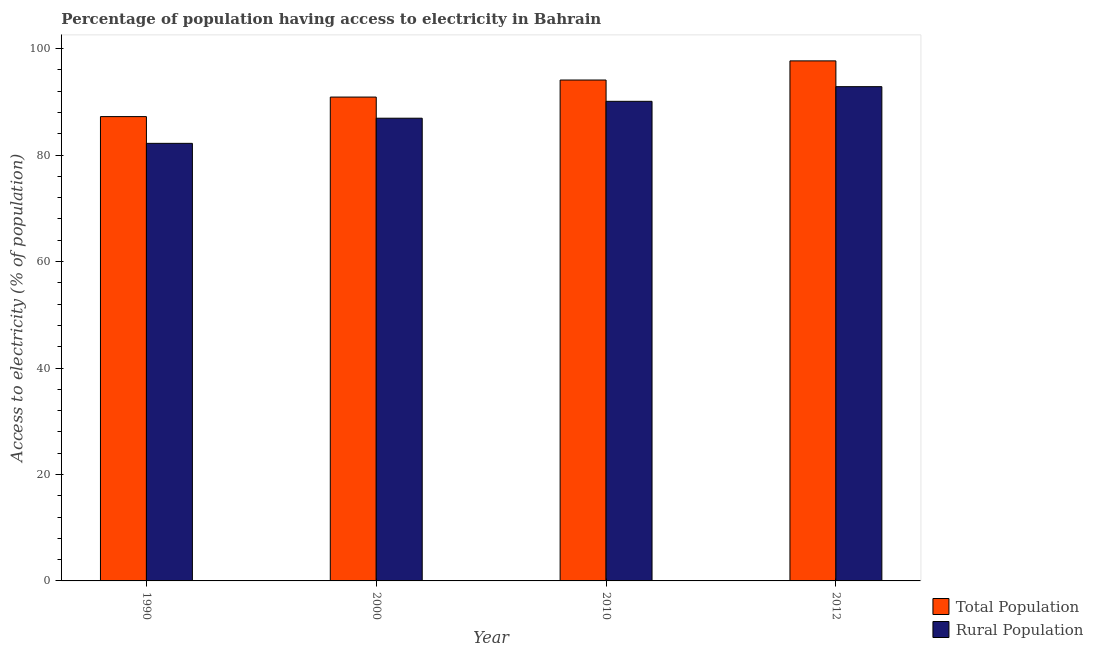How many different coloured bars are there?
Make the answer very short. 2. How many groups of bars are there?
Provide a succinct answer. 4. What is the label of the 3rd group of bars from the left?
Provide a short and direct response. 2010. What is the percentage of population having access to electricity in 1990?
Make the answer very short. 87.23. Across all years, what is the maximum percentage of rural population having access to electricity?
Give a very brief answer. 92.85. Across all years, what is the minimum percentage of population having access to electricity?
Give a very brief answer. 87.23. In which year was the percentage of rural population having access to electricity minimum?
Offer a very short reply. 1990. What is the total percentage of rural population having access to electricity in the graph?
Make the answer very short. 352.08. What is the difference between the percentage of population having access to electricity in 2000 and that in 2012?
Provide a short and direct response. -6.8. What is the difference between the percentage of population having access to electricity in 2000 and the percentage of rural population having access to electricity in 2012?
Offer a terse response. -6.8. What is the average percentage of population having access to electricity per year?
Offer a very short reply. 92.48. What is the ratio of the percentage of population having access to electricity in 1990 to that in 2010?
Ensure brevity in your answer.  0.93. What is the difference between the highest and the second highest percentage of rural population having access to electricity?
Give a very brief answer. 2.75. What is the difference between the highest and the lowest percentage of population having access to electricity?
Your answer should be compact. 10.47. In how many years, is the percentage of rural population having access to electricity greater than the average percentage of rural population having access to electricity taken over all years?
Ensure brevity in your answer.  2. What does the 1st bar from the left in 1990 represents?
Keep it short and to the point. Total Population. What does the 2nd bar from the right in 1990 represents?
Offer a terse response. Total Population. Are all the bars in the graph horizontal?
Your answer should be very brief. No. What is the difference between two consecutive major ticks on the Y-axis?
Offer a very short reply. 20. Are the values on the major ticks of Y-axis written in scientific E-notation?
Offer a very short reply. No. Does the graph contain any zero values?
Ensure brevity in your answer.  No. Does the graph contain grids?
Give a very brief answer. No. How are the legend labels stacked?
Provide a short and direct response. Vertical. What is the title of the graph?
Give a very brief answer. Percentage of population having access to electricity in Bahrain. What is the label or title of the X-axis?
Provide a succinct answer. Year. What is the label or title of the Y-axis?
Offer a very short reply. Access to electricity (% of population). What is the Access to electricity (% of population) of Total Population in 1990?
Offer a very short reply. 87.23. What is the Access to electricity (% of population) of Rural Population in 1990?
Your response must be concise. 82.2. What is the Access to electricity (% of population) of Total Population in 2000?
Your response must be concise. 90.9. What is the Access to electricity (% of population) of Rural Population in 2000?
Ensure brevity in your answer.  86.93. What is the Access to electricity (% of population) in Total Population in 2010?
Your answer should be very brief. 94.1. What is the Access to electricity (% of population) of Rural Population in 2010?
Offer a very short reply. 90.1. What is the Access to electricity (% of population) in Total Population in 2012?
Your answer should be compact. 97.7. What is the Access to electricity (% of population) in Rural Population in 2012?
Provide a short and direct response. 92.85. Across all years, what is the maximum Access to electricity (% of population) of Total Population?
Make the answer very short. 97.7. Across all years, what is the maximum Access to electricity (% of population) of Rural Population?
Provide a short and direct response. 92.85. Across all years, what is the minimum Access to electricity (% of population) of Total Population?
Provide a succinct answer. 87.23. Across all years, what is the minimum Access to electricity (% of population) in Rural Population?
Offer a terse response. 82.2. What is the total Access to electricity (% of population) in Total Population in the graph?
Make the answer very short. 369.92. What is the total Access to electricity (% of population) of Rural Population in the graph?
Your answer should be very brief. 352.08. What is the difference between the Access to electricity (% of population) of Total Population in 1990 and that in 2000?
Offer a terse response. -3.67. What is the difference between the Access to electricity (% of population) of Rural Population in 1990 and that in 2000?
Give a very brief answer. -4.72. What is the difference between the Access to electricity (% of population) in Total Population in 1990 and that in 2010?
Give a very brief answer. -6.87. What is the difference between the Access to electricity (% of population) of Rural Population in 1990 and that in 2010?
Your answer should be very brief. -7.9. What is the difference between the Access to electricity (% of population) of Total Population in 1990 and that in 2012?
Offer a terse response. -10.47. What is the difference between the Access to electricity (% of population) of Rural Population in 1990 and that in 2012?
Your response must be concise. -10.65. What is the difference between the Access to electricity (% of population) of Total Population in 2000 and that in 2010?
Your response must be concise. -3.2. What is the difference between the Access to electricity (% of population) of Rural Population in 2000 and that in 2010?
Your answer should be compact. -3.17. What is the difference between the Access to electricity (% of population) of Total Population in 2000 and that in 2012?
Your response must be concise. -6.8. What is the difference between the Access to electricity (% of population) in Rural Population in 2000 and that in 2012?
Your answer should be compact. -5.93. What is the difference between the Access to electricity (% of population) of Total Population in 2010 and that in 2012?
Your response must be concise. -3.6. What is the difference between the Access to electricity (% of population) in Rural Population in 2010 and that in 2012?
Your response must be concise. -2.75. What is the difference between the Access to electricity (% of population) of Total Population in 1990 and the Access to electricity (% of population) of Rural Population in 2000?
Your answer should be compact. 0.3. What is the difference between the Access to electricity (% of population) of Total Population in 1990 and the Access to electricity (% of population) of Rural Population in 2010?
Give a very brief answer. -2.87. What is the difference between the Access to electricity (% of population) in Total Population in 1990 and the Access to electricity (% of population) in Rural Population in 2012?
Offer a very short reply. -5.63. What is the difference between the Access to electricity (% of population) of Total Population in 2000 and the Access to electricity (% of population) of Rural Population in 2010?
Provide a succinct answer. 0.8. What is the difference between the Access to electricity (% of population) in Total Population in 2000 and the Access to electricity (% of population) in Rural Population in 2012?
Your answer should be compact. -1.96. What is the difference between the Access to electricity (% of population) in Total Population in 2010 and the Access to electricity (% of population) in Rural Population in 2012?
Ensure brevity in your answer.  1.25. What is the average Access to electricity (% of population) in Total Population per year?
Give a very brief answer. 92.48. What is the average Access to electricity (% of population) in Rural Population per year?
Ensure brevity in your answer.  88.02. In the year 1990, what is the difference between the Access to electricity (% of population) in Total Population and Access to electricity (% of population) in Rural Population?
Give a very brief answer. 5.02. In the year 2000, what is the difference between the Access to electricity (% of population) of Total Population and Access to electricity (% of population) of Rural Population?
Provide a short and direct response. 3.97. In the year 2010, what is the difference between the Access to electricity (% of population) of Total Population and Access to electricity (% of population) of Rural Population?
Provide a succinct answer. 4. In the year 2012, what is the difference between the Access to electricity (% of population) of Total Population and Access to electricity (% of population) of Rural Population?
Provide a succinct answer. 4.84. What is the ratio of the Access to electricity (% of population) in Total Population in 1990 to that in 2000?
Provide a succinct answer. 0.96. What is the ratio of the Access to electricity (% of population) of Rural Population in 1990 to that in 2000?
Your answer should be very brief. 0.95. What is the ratio of the Access to electricity (% of population) in Total Population in 1990 to that in 2010?
Give a very brief answer. 0.93. What is the ratio of the Access to electricity (% of population) of Rural Population in 1990 to that in 2010?
Provide a succinct answer. 0.91. What is the ratio of the Access to electricity (% of population) in Total Population in 1990 to that in 2012?
Offer a terse response. 0.89. What is the ratio of the Access to electricity (% of population) in Rural Population in 1990 to that in 2012?
Provide a succinct answer. 0.89. What is the ratio of the Access to electricity (% of population) of Rural Population in 2000 to that in 2010?
Offer a very short reply. 0.96. What is the ratio of the Access to electricity (% of population) of Total Population in 2000 to that in 2012?
Provide a succinct answer. 0.93. What is the ratio of the Access to electricity (% of population) in Rural Population in 2000 to that in 2012?
Ensure brevity in your answer.  0.94. What is the ratio of the Access to electricity (% of population) of Total Population in 2010 to that in 2012?
Your response must be concise. 0.96. What is the ratio of the Access to electricity (% of population) of Rural Population in 2010 to that in 2012?
Ensure brevity in your answer.  0.97. What is the difference between the highest and the second highest Access to electricity (% of population) of Total Population?
Make the answer very short. 3.6. What is the difference between the highest and the second highest Access to electricity (% of population) in Rural Population?
Your response must be concise. 2.75. What is the difference between the highest and the lowest Access to electricity (% of population) of Total Population?
Your answer should be compact. 10.47. What is the difference between the highest and the lowest Access to electricity (% of population) in Rural Population?
Make the answer very short. 10.65. 